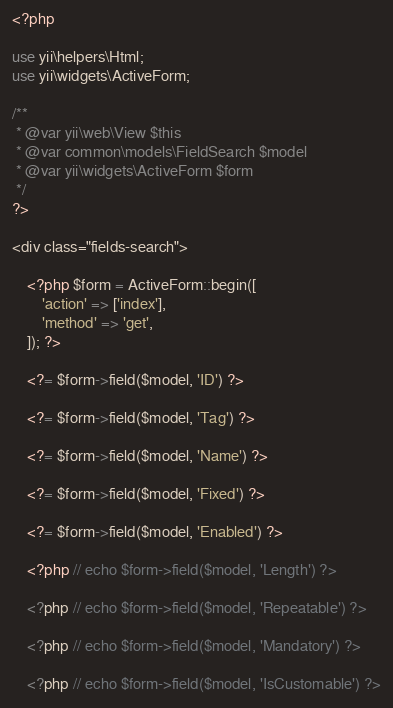<code> <loc_0><loc_0><loc_500><loc_500><_PHP_><?php

use yii\helpers\Html;
use yii\widgets\ActiveForm;

/**
 * @var yii\web\View $this
 * @var common\models\FieldSearch $model
 * @var yii\widgets\ActiveForm $form
 */
?>

<div class="fields-search">

    <?php $form = ActiveForm::begin([
        'action' => ['index'],
        'method' => 'get',
    ]); ?>

    <?= $form->field($model, 'ID') ?>

    <?= $form->field($model, 'Tag') ?>

    <?= $form->field($model, 'Name') ?>

    <?= $form->field($model, 'Fixed') ?>

    <?= $form->field($model, 'Enabled') ?>

    <?php // echo $form->field($model, 'Length') ?>

    <?php // echo $form->field($model, 'Repeatable') ?>

    <?php // echo $form->field($model, 'Mandatory') ?>

    <?php // echo $form->field($model, 'IsCustomable') ?>
</code> 